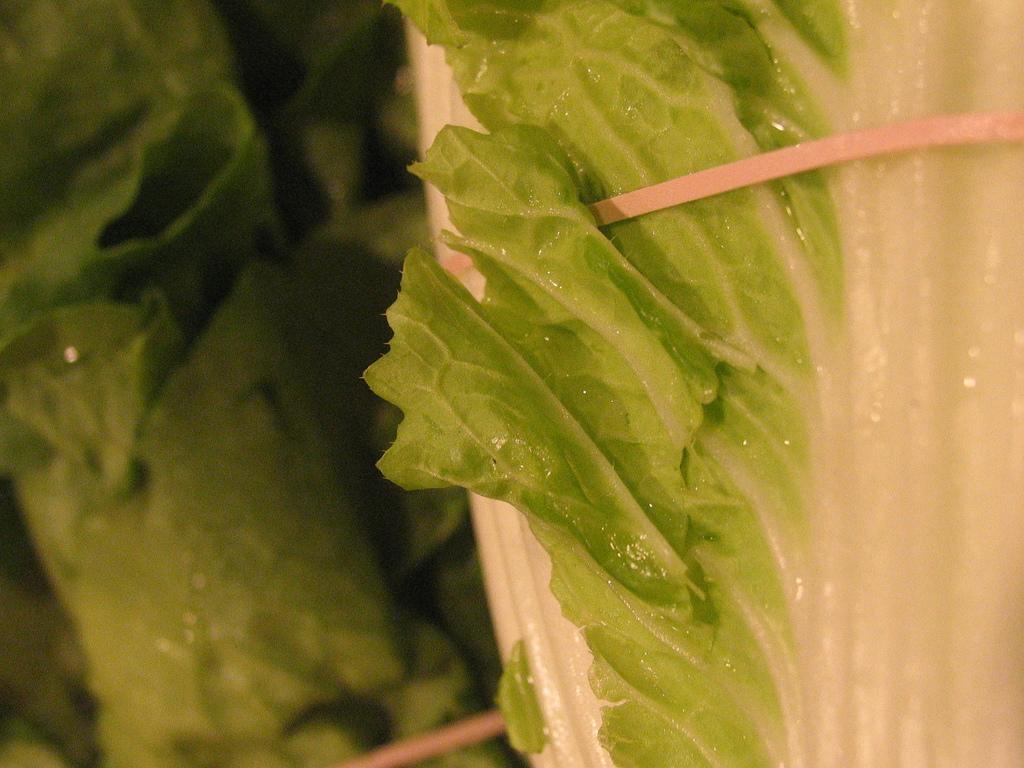Please provide a concise description of this image. In this picture there is a greenery leaf in an object and the background is greenery in the left corner. 